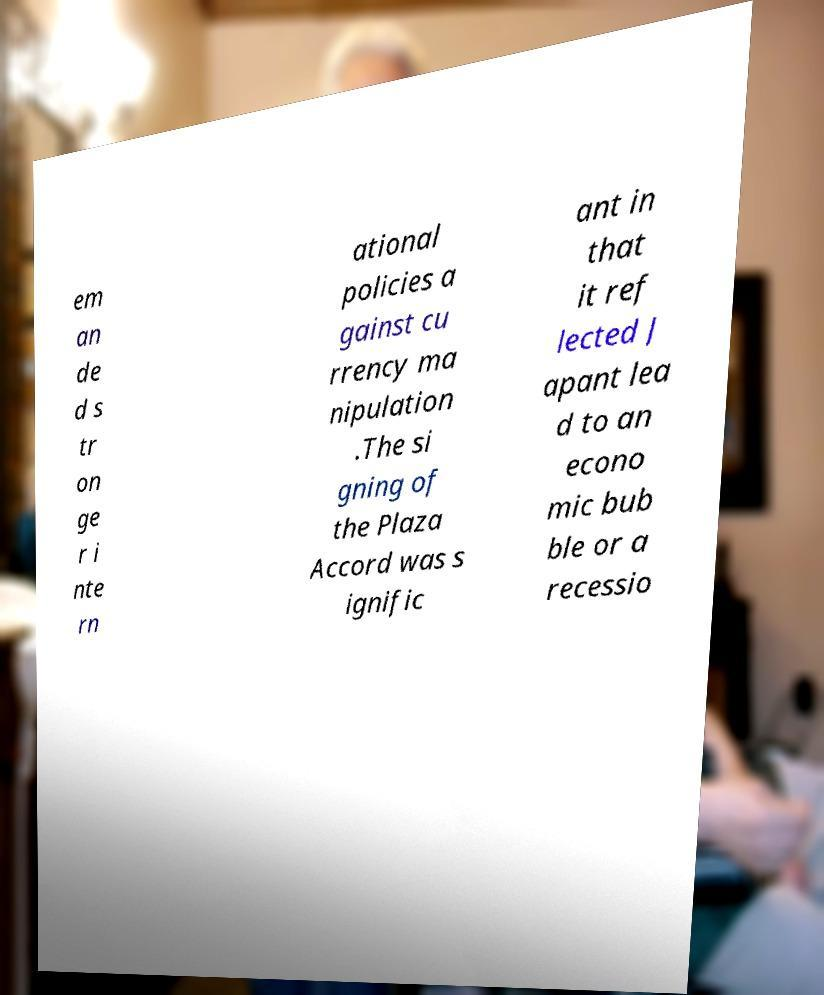I need the written content from this picture converted into text. Can you do that? em an de d s tr on ge r i nte rn ational policies a gainst cu rrency ma nipulation .The si gning of the Plaza Accord was s ignific ant in that it ref lected J apant lea d to an econo mic bub ble or a recessio 